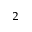<formula> <loc_0><loc_0><loc_500><loc_500>^ { 2 }</formula> 